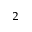<formula> <loc_0><loc_0><loc_500><loc_500>^ { 2 }</formula> 